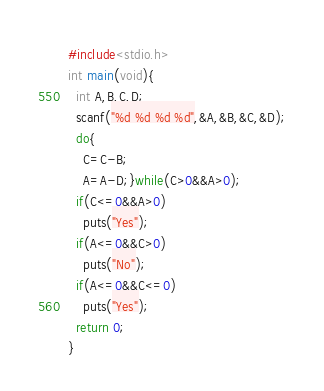Convert code to text. <code><loc_0><loc_0><loc_500><loc_500><_C_>#include<stdio.h>
int main(void){
  int A,B,C,D;
  scanf("%d %d %d %d",&A,&B,&C,&D);
  do{
    C=C-B;
    A=A-D;}while(C>0&&A>0);
  if(C<=0&&A>0)
    puts("Yes");
  if(A<=0&&C>0)
    puts("No");
  if(A<=0&&C<=0)
    puts("Yes");
  return 0;
}</code> 